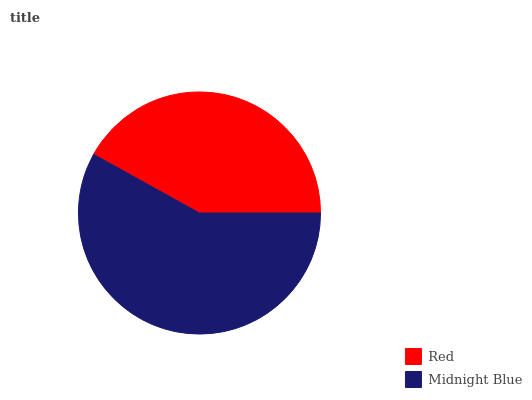Is Red the minimum?
Answer yes or no. Yes. Is Midnight Blue the maximum?
Answer yes or no. Yes. Is Midnight Blue the minimum?
Answer yes or no. No. Is Midnight Blue greater than Red?
Answer yes or no. Yes. Is Red less than Midnight Blue?
Answer yes or no. Yes. Is Red greater than Midnight Blue?
Answer yes or no. No. Is Midnight Blue less than Red?
Answer yes or no. No. Is Midnight Blue the high median?
Answer yes or no. Yes. Is Red the low median?
Answer yes or no. Yes. Is Red the high median?
Answer yes or no. No. Is Midnight Blue the low median?
Answer yes or no. No. 